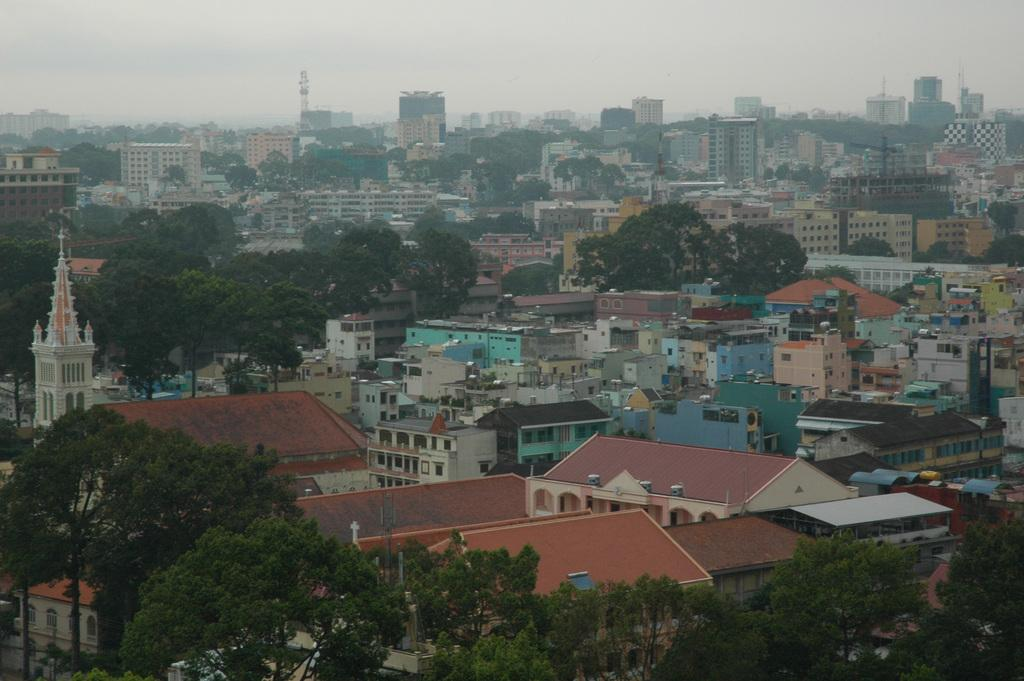What type of structures are present in the image? There is a group of buildings, including a tower and houses with roofs and windows, in the image. Can you describe the vegetation in the image? There is a group of trees in the image. What is visible in the sky in the image? The sky is visible in the image and appears cloudy. What type of pancake is being served at the edge of the image? There is no pancake present in the image, and the concept of an "edge" of the image is not applicable, as the image is a two-dimensional representation. 